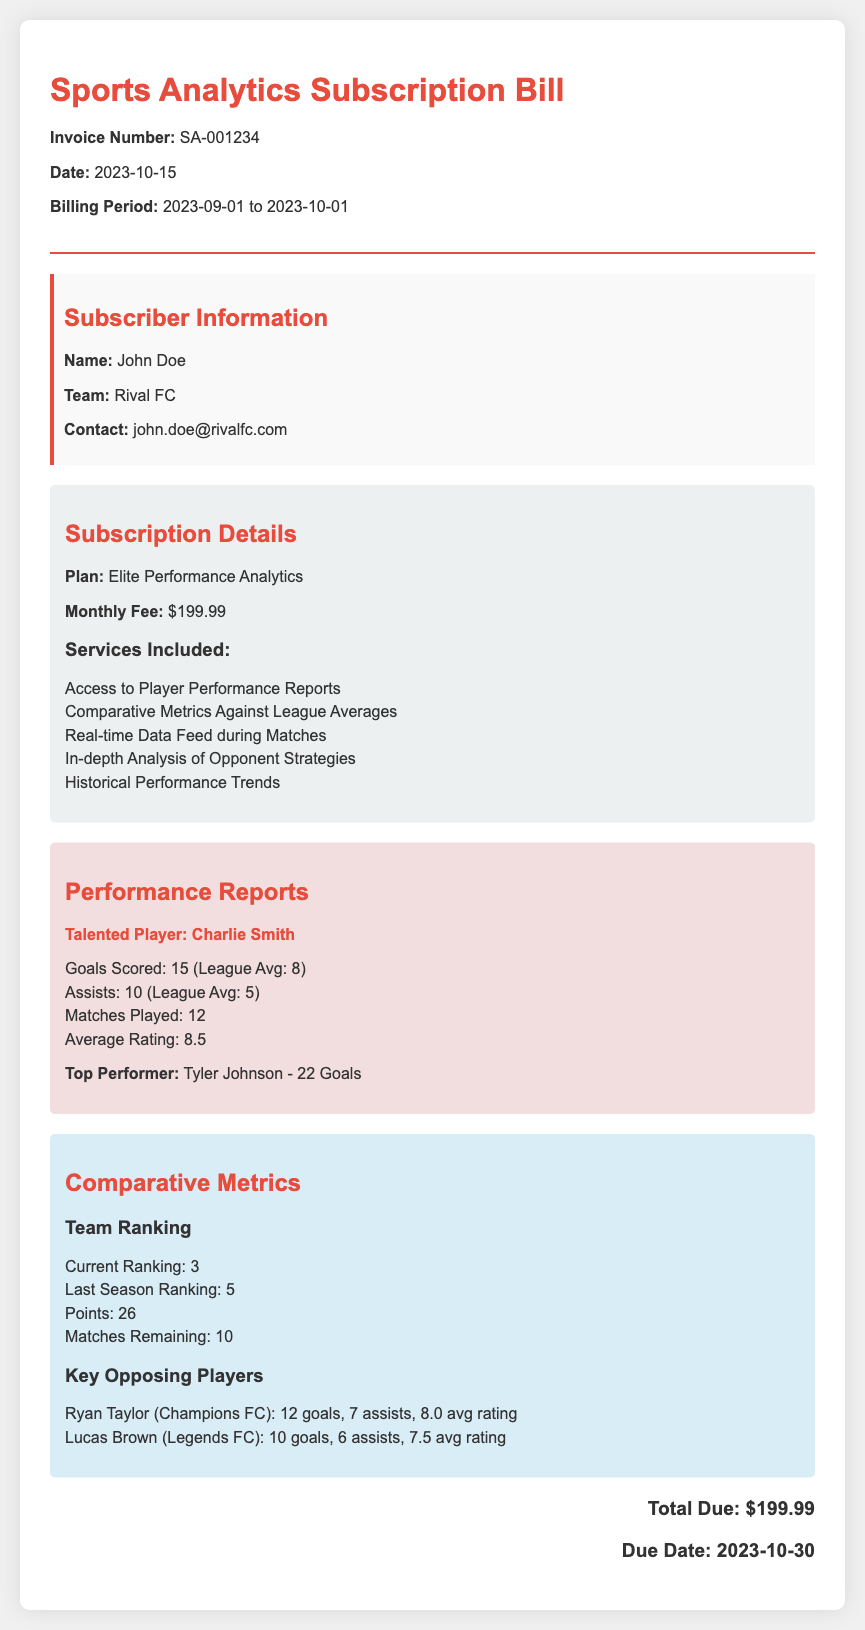What is the invoice number? The invoice number is clearly provided in the header of the document.
Answer: SA-001234 What is the monthly fee for the subscription? The subscription details section specifies the monthly fee for the selected plan.
Answer: $199.99 Who is the talented player mentioned in the performance reports? The performance reports highlight the talented player based on the metrics provided.
Answer: Charlie Smith How many goals has the top performer scored? The performance reports indicate the achievements of the top performer.
Answer: 22 Goals What is the current ranking of the team? The comparative metrics section lists the current ranking of the team.
Answer: 3 What was the last season's ranking of the team? The document compares current and past performance by stating the last season's ranking.
Answer: 5 What is the due date for the payment? The total due section mentions the due date for the subscription payment.
Answer: 2023-10-30 What are the services included in the subscription plan? The subscription details section lists various services included with the plan.
Answer: Access to Player Performance Reports, Comparative Metrics Against League Averages, Real-time Data Feed during Matches, In-depth Analysis of Opponent Strategies, Historical Performance Trends How many assists has Charlie Smith made? The performance reports provide specific statistics for Charlie Smith's performance during the season.
Answer: 10 